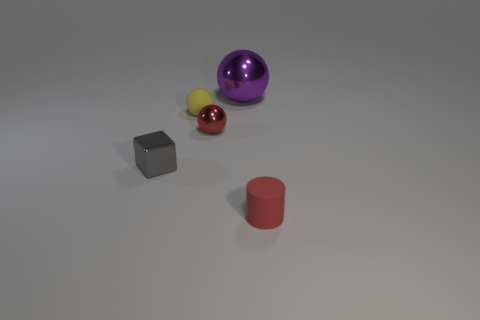There is a tiny yellow thing that is the same shape as the large purple shiny object; what is it made of?
Give a very brief answer. Rubber. There is a tiny cylinder; are there any large purple spheres in front of it?
Your answer should be compact. No. Are the small thing in front of the small gray thing and the large purple ball made of the same material?
Offer a terse response. No. Is there a tiny metallic cube that has the same color as the large shiny sphere?
Ensure brevity in your answer.  No. What shape is the red shiny thing?
Your answer should be very brief. Sphere. There is a small block that is behind the matte thing that is right of the large purple ball; what color is it?
Offer a terse response. Gray. There is a rubber object left of the big purple metallic thing; how big is it?
Your answer should be compact. Small. Is there a large sphere made of the same material as the cylinder?
Provide a short and direct response. No. How many small rubber objects have the same shape as the large purple thing?
Make the answer very short. 1. What is the shape of the red object that is in front of the tiny shiny object in front of the tiny shiny object that is behind the metal cube?
Make the answer very short. Cylinder. 